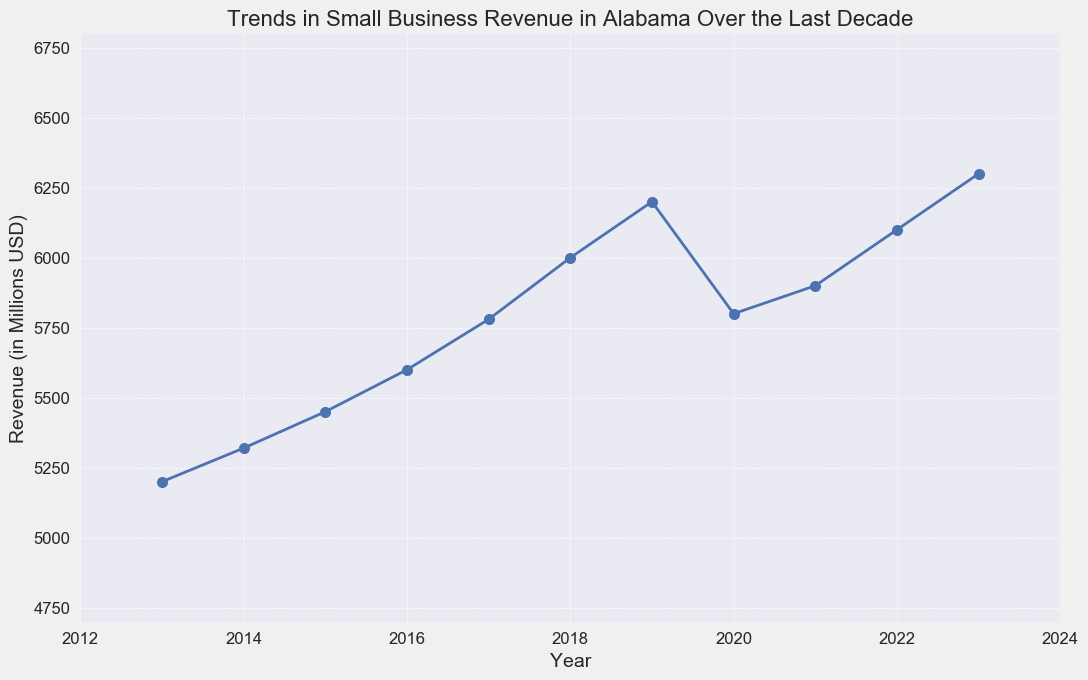What was the revenue trend from 2013 to 2019? The revenue trend shows continual growth from 2013 ($5200 million) to 2019 ($6200 million). Each year there is an increase.
Answer: Continual growth Which year had the biggest drop in revenue? The year 2020 had the biggest drop in revenue, decreasing from $6200 million in 2019 to $5800 million in 2020. This is a difference of $400 million.
Answer: 2020 Was there any year where the revenue stayed the same as the previous year? There was no year where the revenue stayed the same. The revenue was either increasing or decreasing each year.
Answer: No What is the difference in revenue between the highest and lowest revenue years? The highest revenue year is 2023 with $6300 million, and the lowest is 2013 with $5200 million. The difference is $6300 million - $5200 million = $1100 million.
Answer: $1100 million How did the revenue change between 2019 and 2021? The revenue decreased from $6200 million in 2019 to $5800 million in 2020, and slightly increased to $5900 million in 2021. So, there was an initial decrease followed by a small increase.
Answer: Decreased then increased What is the average revenue from 2013 to 2023? The sum of revenues from 2013 to 2023 is 5200 + 5320 + 5450 + 5600 + 5780 + 6000 + 6200 + 5800 + 5900 + 6100 + 6300 = 63650 million USD. Dividing this by 11 (the number of years) gives an average revenue of approximately $5786.36 million.
Answer: $5786.36 million Did the revenue increase faster before or after 2016? Before 2016 (2013-2015), the revenue increased by 5450 - 5200 = $250 million. After 2016 (2017-2023), the revenue increased by 6300 - 5600 = $700 million. Therefore, the revenue increased faster after 2016.
Answer: After 2016 How did the revenue change in the year 2021 compare to 2020? The revenue in 2021 was $5900 million, which is higher than $5800 million in 2020. Thus, the revenue increased by $100 million from 2020 to 2021.
Answer: Increased by $100 million Which year had the highest revenue? The year 2023 had the highest revenue at $6300 million.
Answer: 2023 Between which two consecutive years was the smallest revenue change? The smallest revenue change was between 2020 and 2021, where the revenue increased from $5800 million to $5900 million, a difference of $100 million.
Answer: 2020 and 2021 